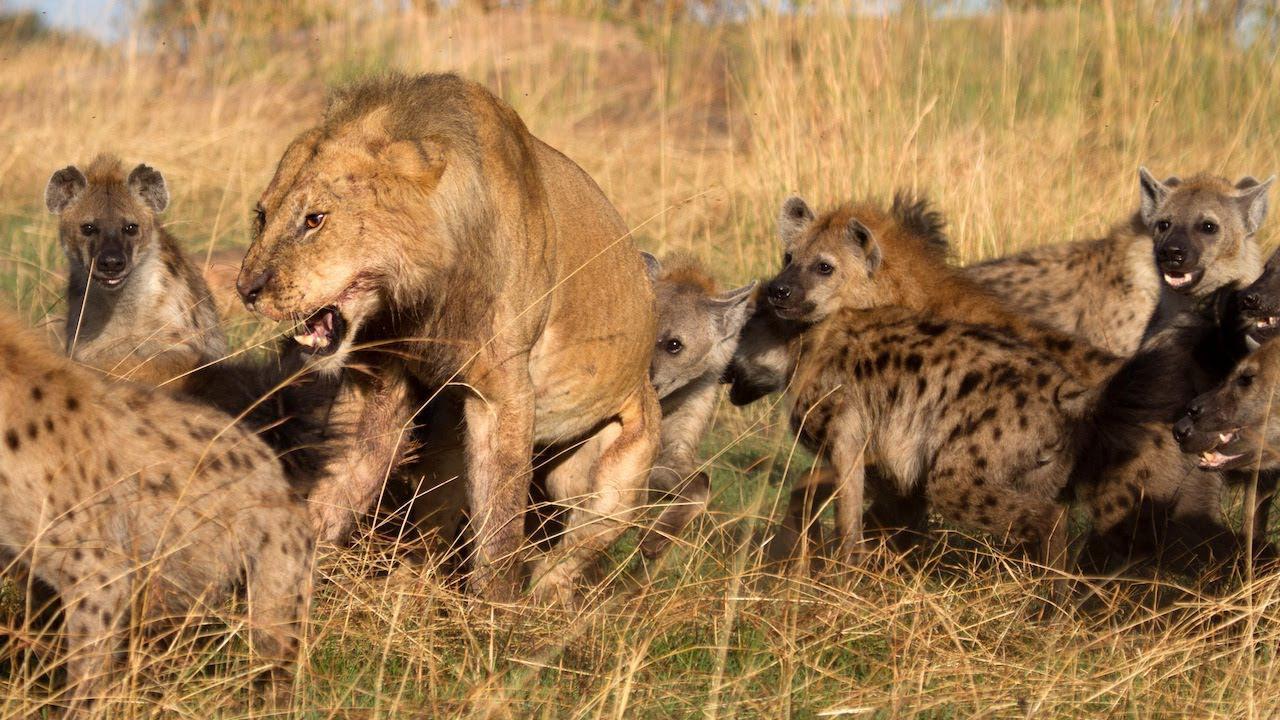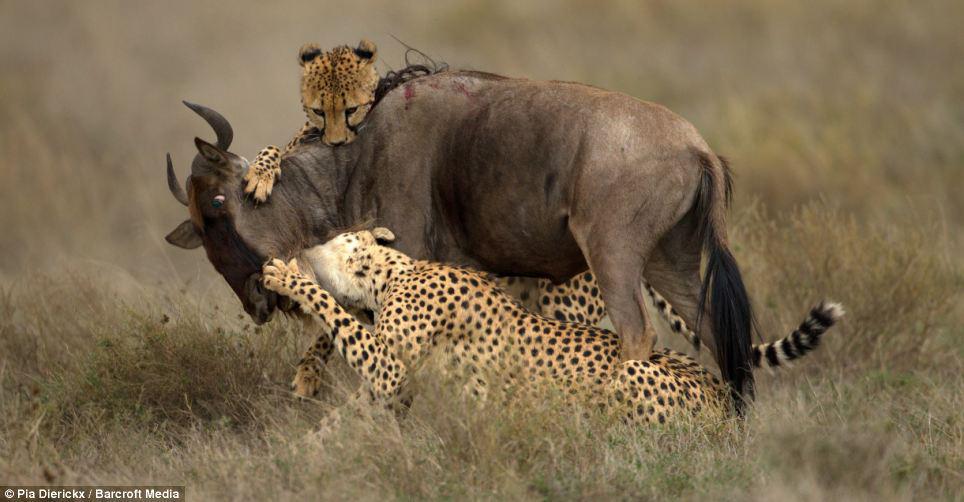The first image is the image on the left, the second image is the image on the right. Assess this claim about the two images: "One of the images only contains hyenas". Correct or not? Answer yes or no. No. The first image is the image on the left, the second image is the image on the right. Evaluate the accuracy of this statement regarding the images: "One image shows hyenas around an open-mouthed lion.". Is it true? Answer yes or no. Yes. 